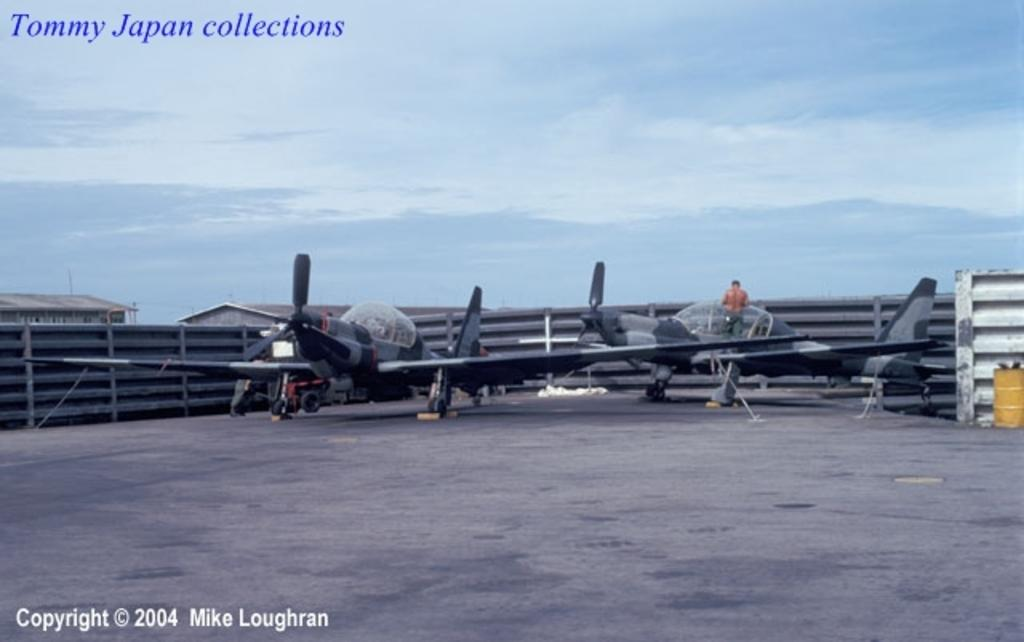What can be seen on the floor in the image? There are aircrafts on the floor in the image. Is there anyone inside the aircrafts? Yes, a person is present in one of the aircrafts. What can be seen in the background of the image? There is sky visible in the background of the image, with clouds present. There are also walls and sheds in the background. Can you find the receipt for the aircrafts in the image? There is no receipt present in the image; it only shows the aircrafts on the floor and the person inside one of them. 